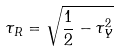Convert formula to latex. <formula><loc_0><loc_0><loc_500><loc_500>\tau _ { R } = \sqrt { \frac { 1 } { 2 } - \tau _ { Y } ^ { 2 } }</formula> 